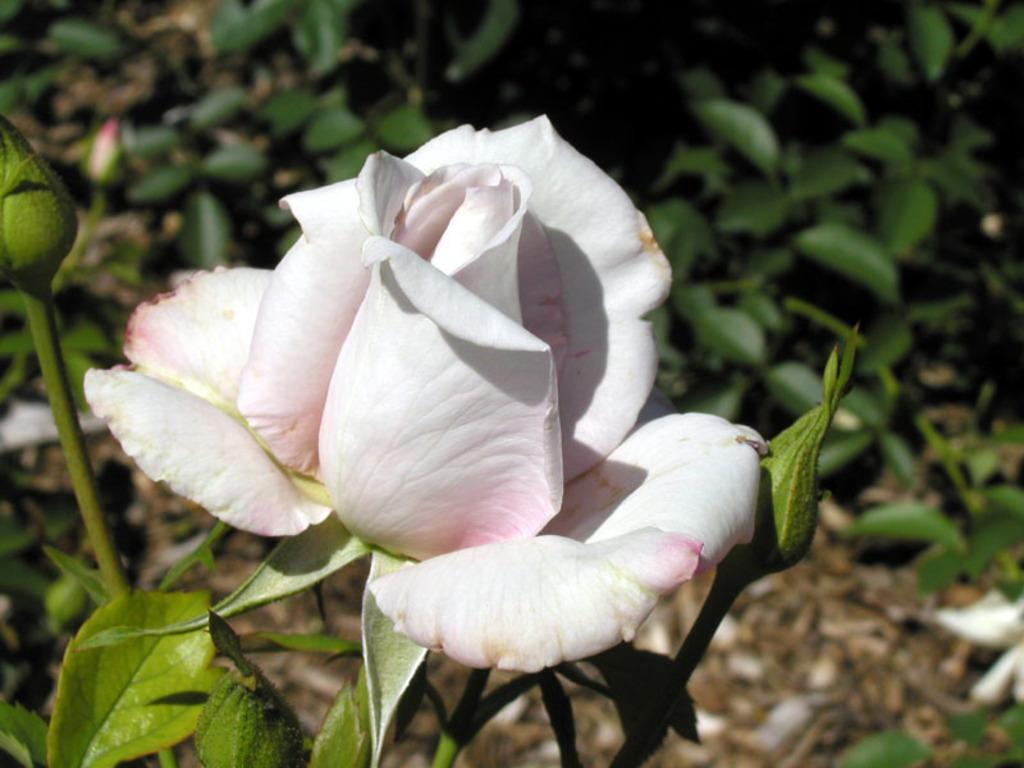What type of flower is in the image? There is a rose flower in the image. Are there any unopened flowers in the image? Yes, there are rose buds in the image. What can be seen in the background of the image? There are plants and the ground visible in the background of the image. What does the mother say about the property at night in the image? There is no mother, property, or night mentioned in the image; it features a rose flower and rose buds with plants and the ground in the background. 